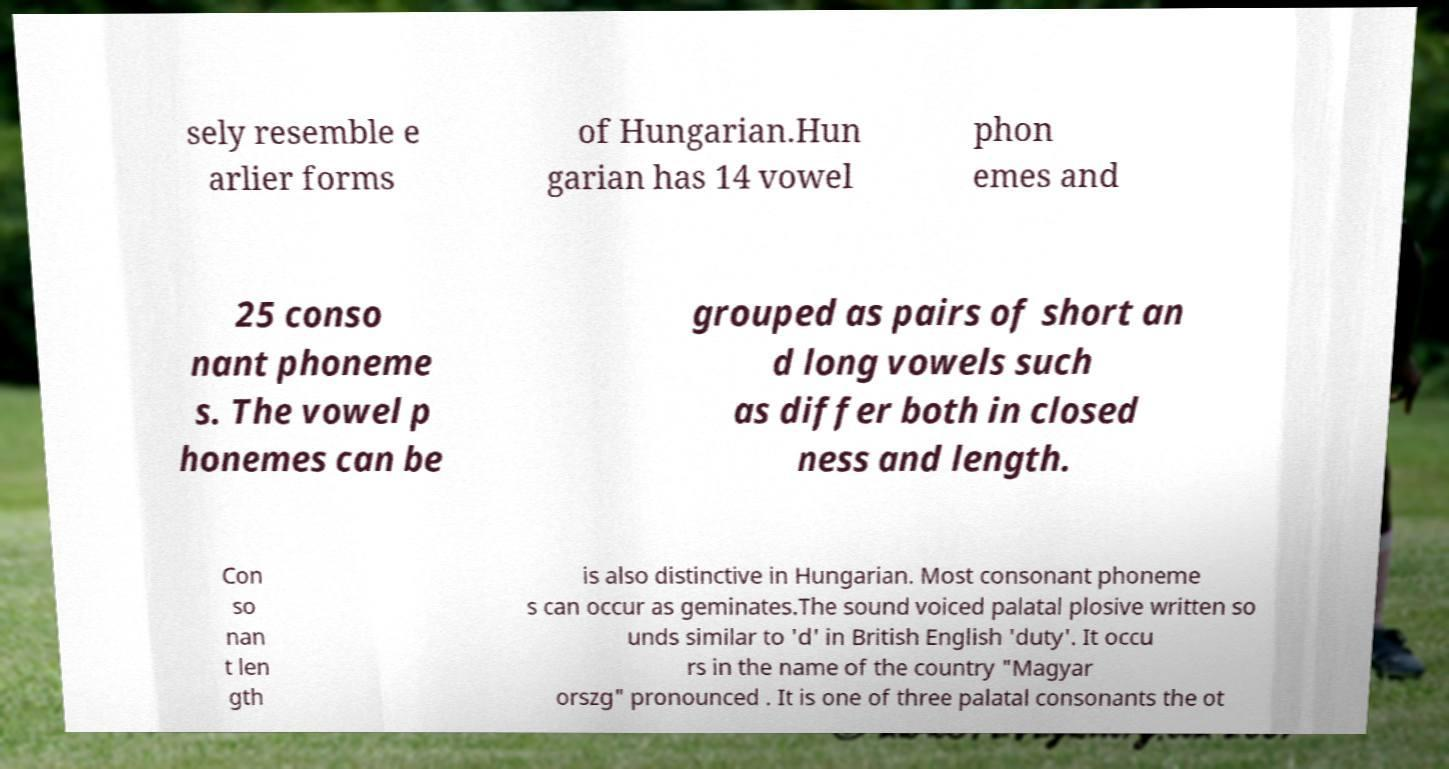Can you accurately transcribe the text from the provided image for me? sely resemble e arlier forms of Hungarian.Hun garian has 14 vowel phon emes and 25 conso nant phoneme s. The vowel p honemes can be grouped as pairs of short an d long vowels such as differ both in closed ness and length. Con so nan t len gth is also distinctive in Hungarian. Most consonant phoneme s can occur as geminates.The sound voiced palatal plosive written so unds similar to 'd' in British English 'duty'. It occu rs in the name of the country "Magyar orszg" pronounced . It is one of three palatal consonants the ot 